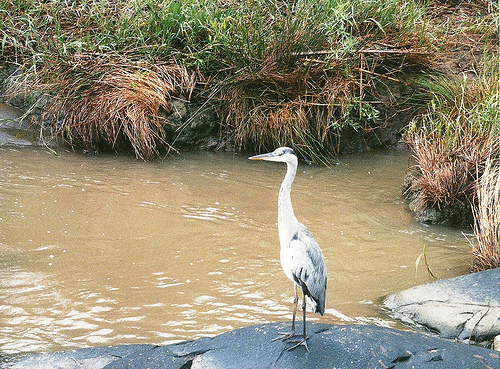<image>
Is the bird to the right of the plant? Yes. From this viewpoint, the bird is positioned to the right side relative to the plant. 